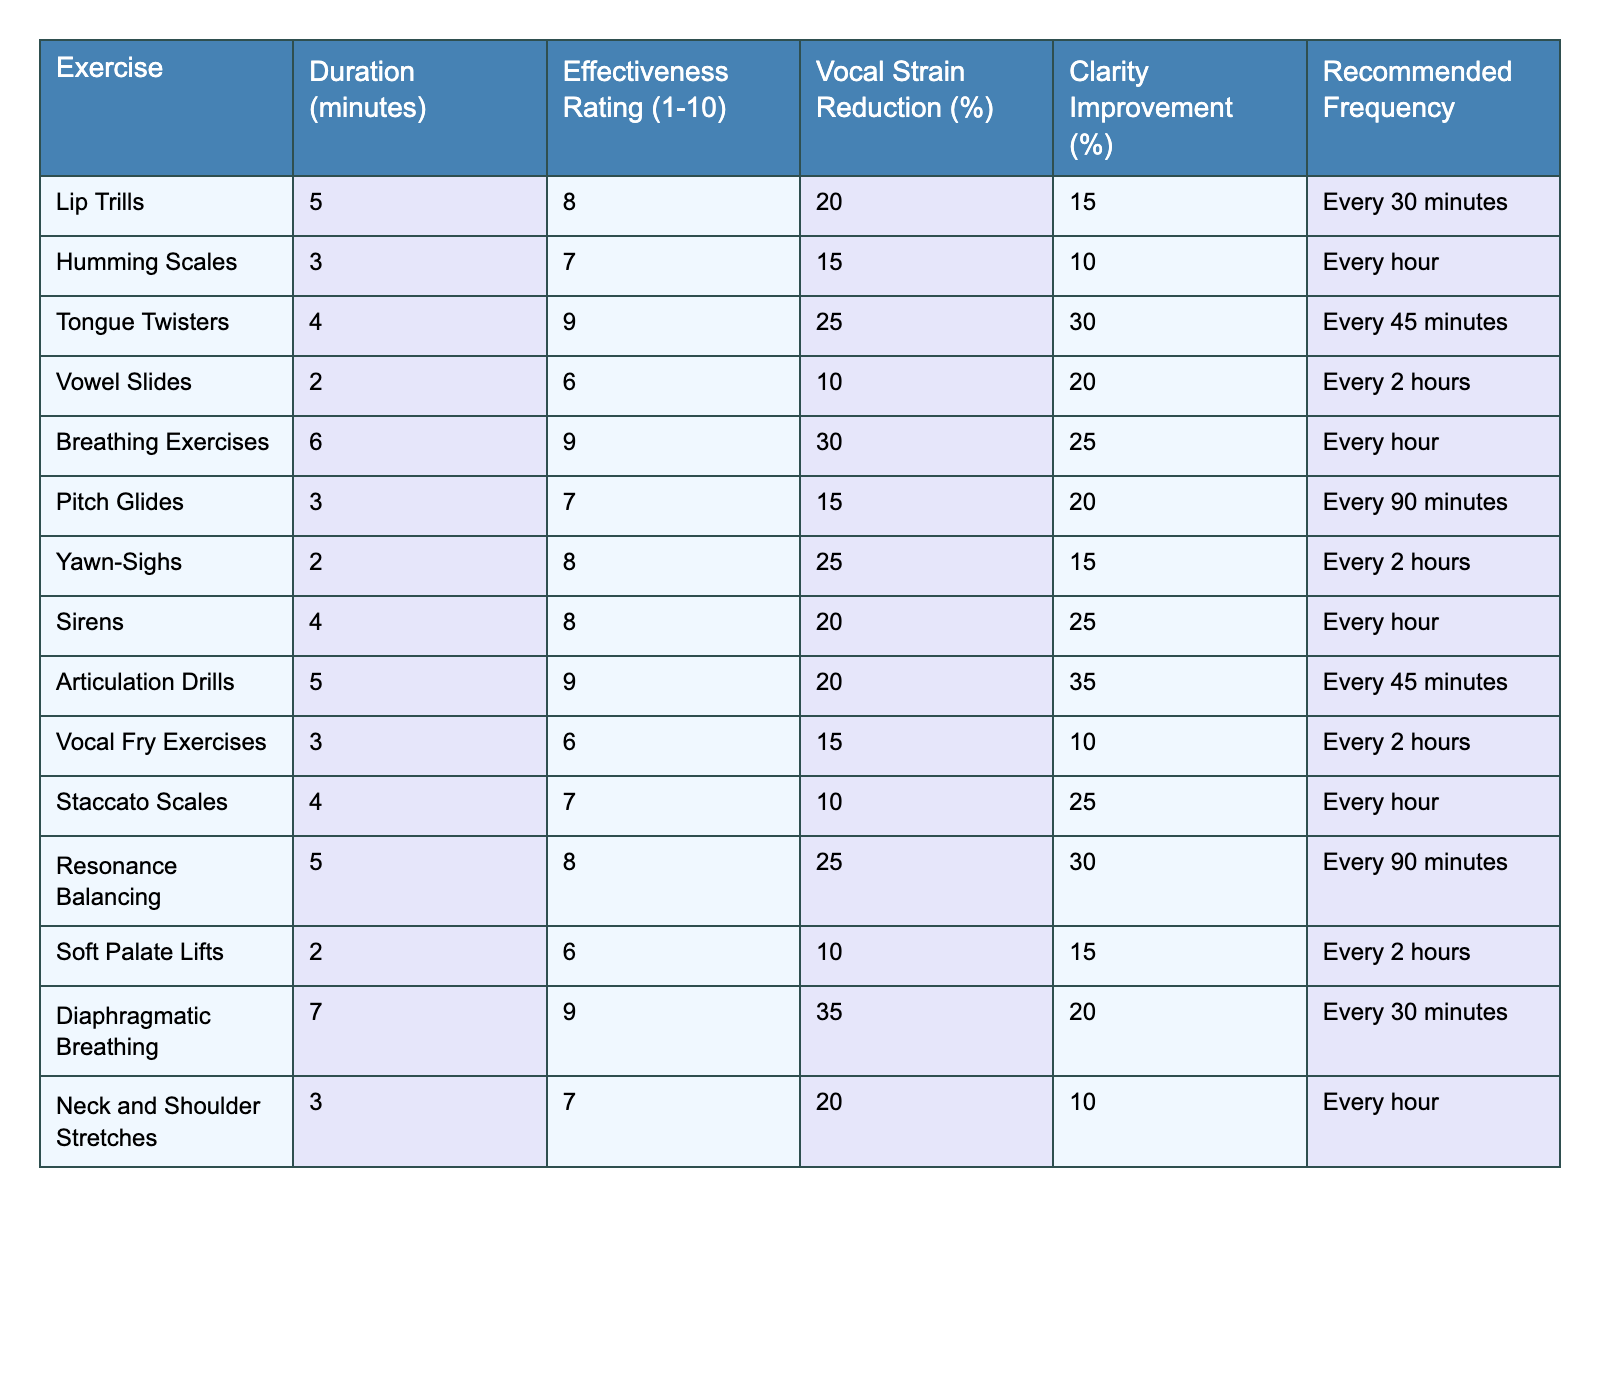What is the effectiveness rating of Lip Trills? Lip Trills have an effectiveness rating of 8 on a scale of 1 to 10, as stated in the table.
Answer: 8 Which exercise has the highest vocal strain reduction percentage? Tongue Twisters show the highest vocal strain reduction with 25%, according to the table data.
Answer: 25% How long does the Diaphragmatic Breathing exercise last? The Diaphragmatic Breathing exercise lasts for 7 minutes as per the information provided in the table.
Answer: 7 minutes Does Yawn-Sighs improve clarity by more than 20%? According to the table, Yawn-Sighs improve clarity by 15%, which is not more than 20%, making the statement false.
Answer: No What is the recommended frequency for taking Breathing Exercises? The table indicates that Breathing Exercises should be performed every hour.
Answer: Every hour Which exercise has a duration of less than 3 minutes? The table shows that Vowel Slides and Soft Palate Lifts last only 2 minutes, making them the exercises under 3 minutes.
Answer: None Calculate the average effectiveness rating of all exercises listed. The total sum of the effectiveness ratings is 8 + 7 + 9 + 6 + 9 + 7 + 8 + 8 + 9 + 6 + 7 + 8 + 9 + 7 = 108. There are 14 exercises, so the average is 108/14 = 7.71.
Answer: 7.71 Which exercise provides the highest improvement in clarity? Articulation Drills provide the highest improvement in clarity at 35%, according to the table data.
Answer: 35% What are the two exercises that have a duration of exactly 4 minutes? The two exercises lasting exactly 4 minutes are Tongue Twisters and Staccato Scales as per the table.
Answer: Tongue Twisters, Staccato Scales Is the duration of Vocal Fry Exercises more than that of Sirens? The table shows Vocal Fry Exercises last 3 minutes while Sirens last 4 minutes, making the statement false.
Answer: No 